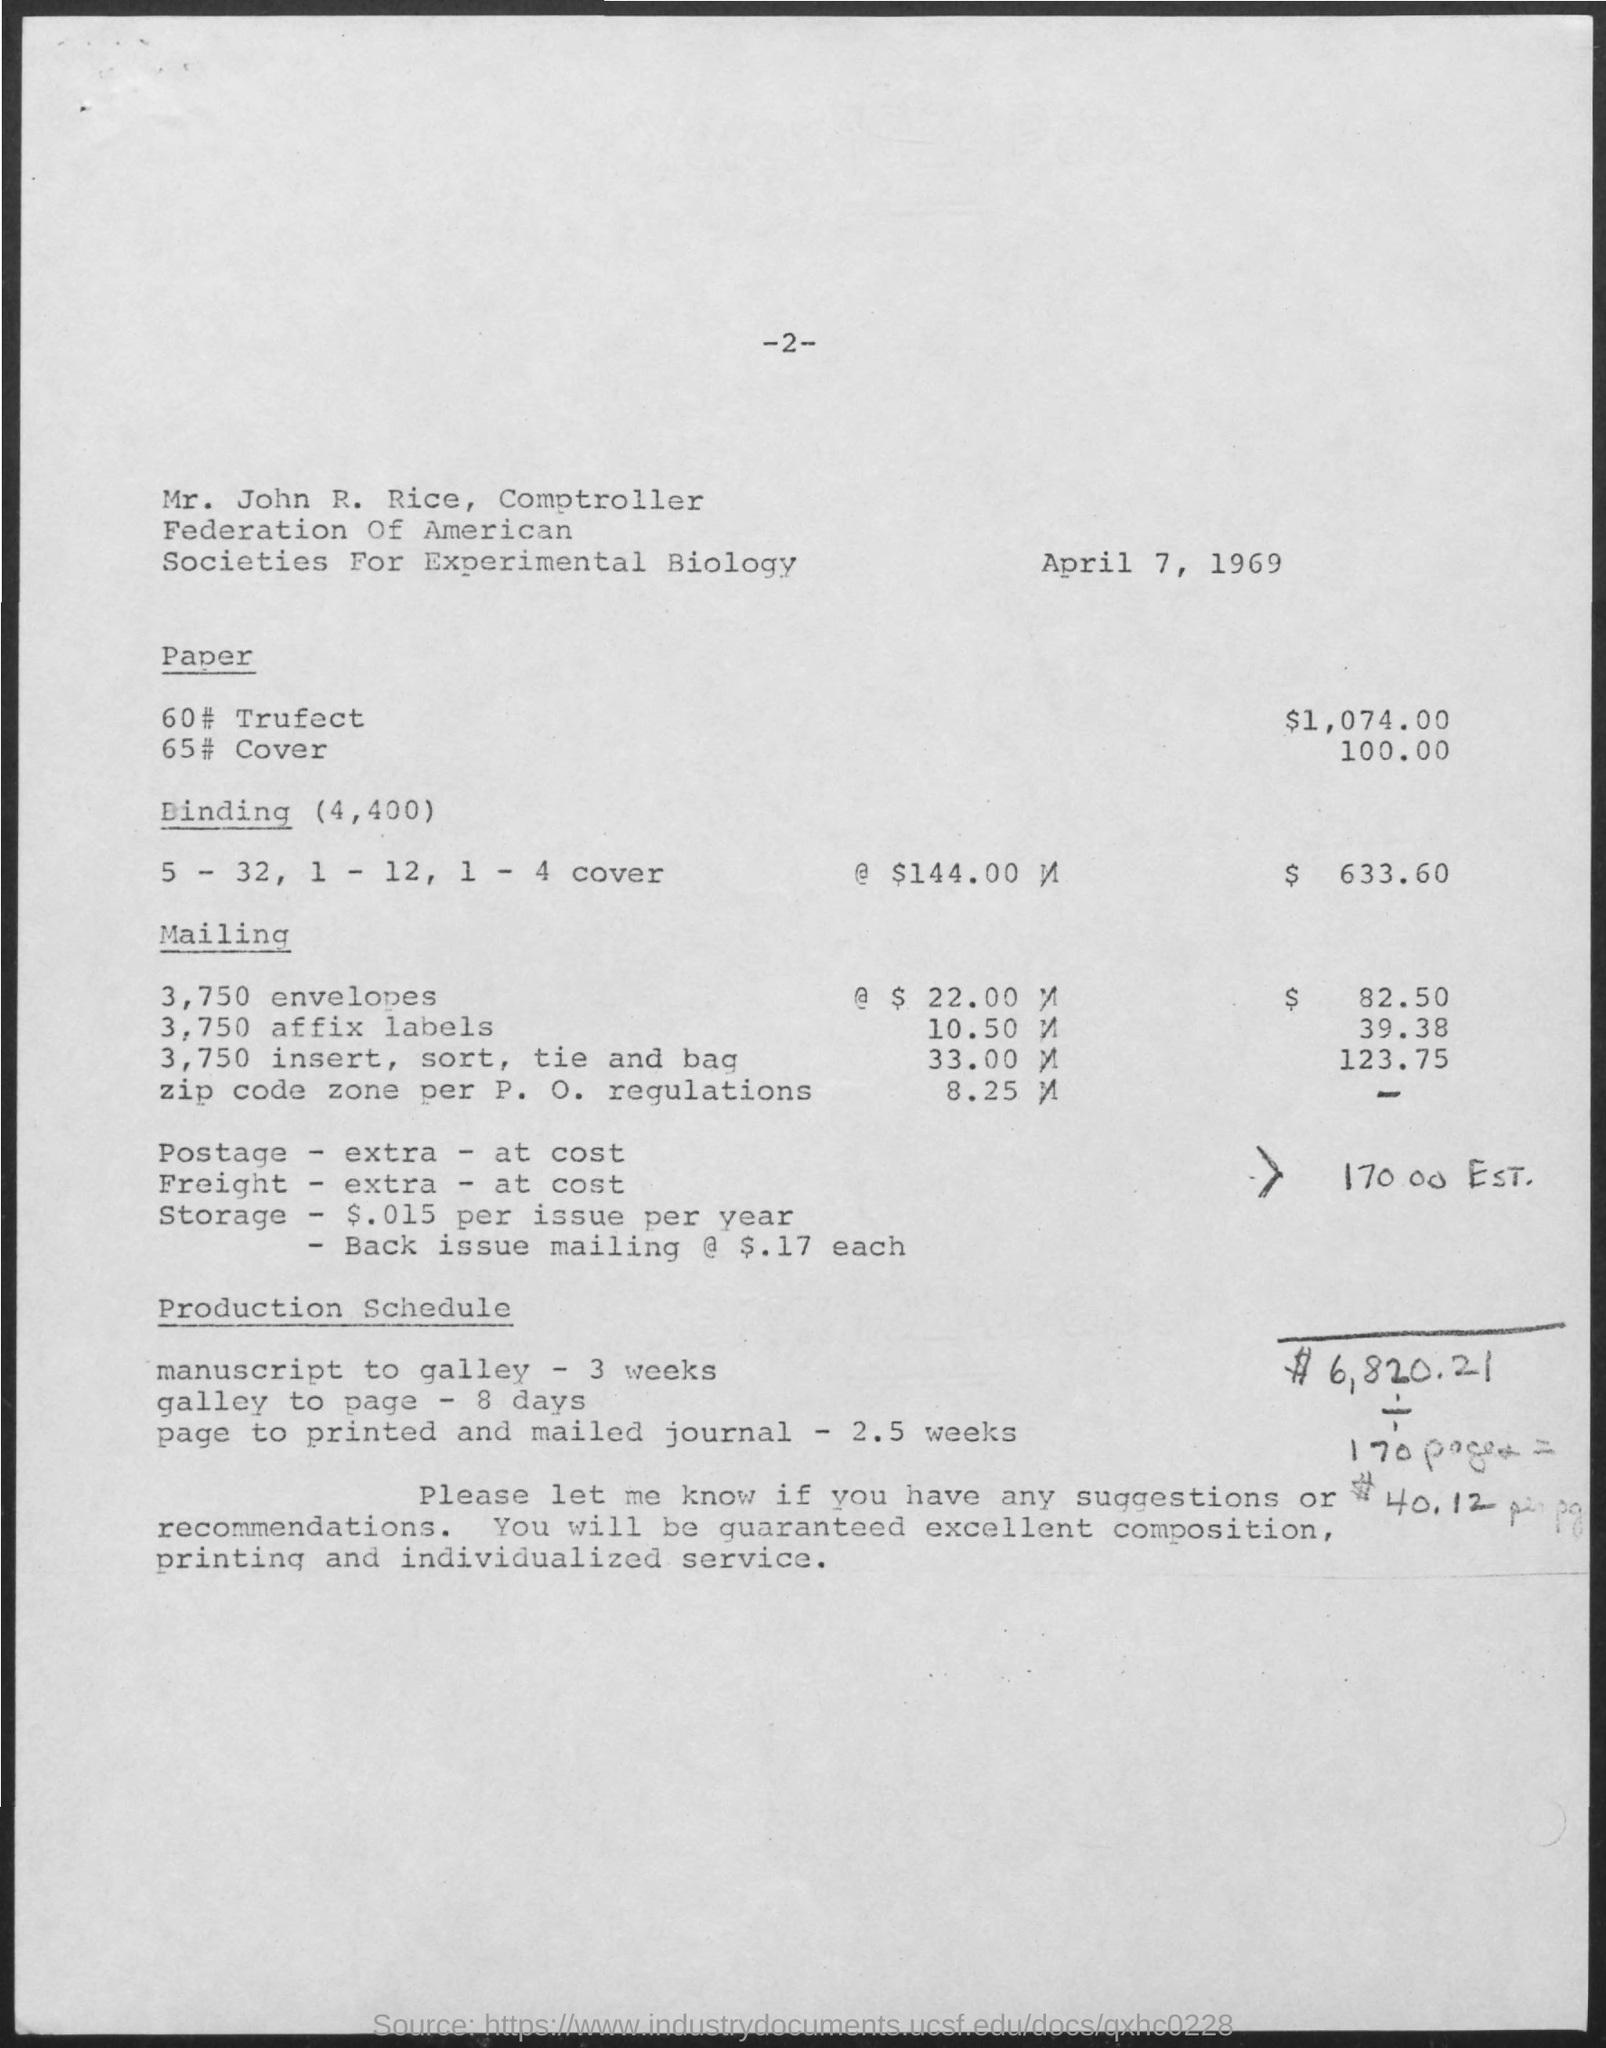What is the page number at top of the page?
Provide a succinct answer. 2. Who is the comptroller of federation of american societies for experimental biology?
Keep it short and to the point. Mr. John R. Rice. What is the date and year mentioned at top of the page?
Ensure brevity in your answer.  April 7, 1969. What is the cost of binding?
Make the answer very short. $ 633.60. What is the cost of paper 60# trufect?
Ensure brevity in your answer.  $1,074.00. 